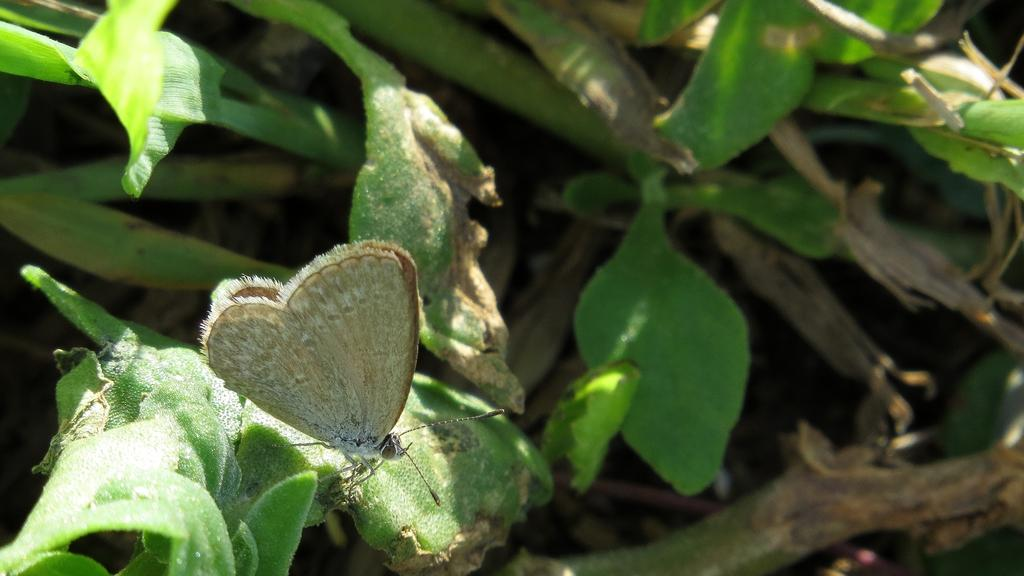What type of insect is present in the image? There is a butterfly in the image. What type of vegetation can be seen in the image? There are leaves visible in the image. What type of dirt can be seen on the butterfly's wings in the image? There is no dirt visible on the butterfly's wings in the image. What territory does the butterfly claim as its own in the image? Butterflies do not claim territories, so this question cannot be answered definitively from the image. 